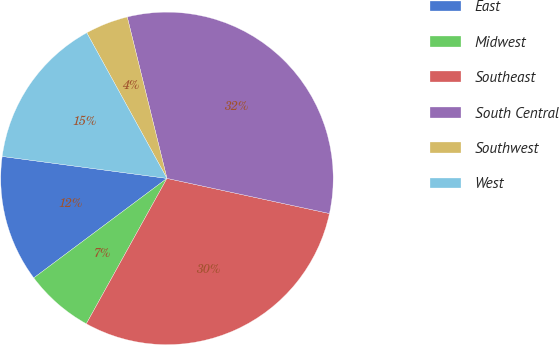Convert chart to OTSL. <chart><loc_0><loc_0><loc_500><loc_500><pie_chart><fcel>East<fcel>Midwest<fcel>Southeast<fcel>South Central<fcel>Southwest<fcel>West<nl><fcel>12.32%<fcel>6.73%<fcel>29.67%<fcel>32.23%<fcel>4.17%<fcel>14.88%<nl></chart> 